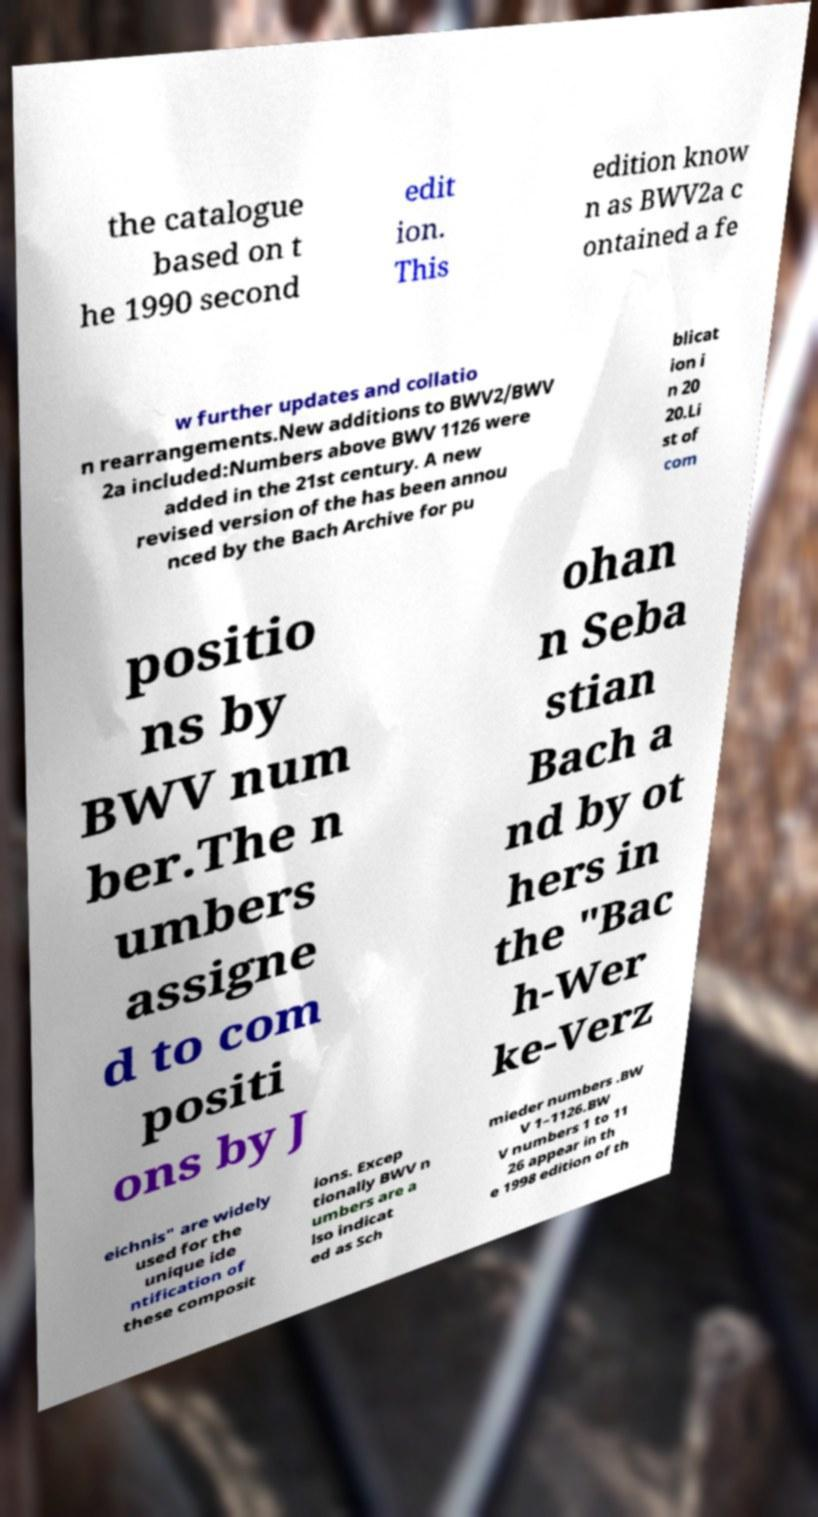For documentation purposes, I need the text within this image transcribed. Could you provide that? the catalogue based on t he 1990 second edit ion. This edition know n as BWV2a c ontained a fe w further updates and collatio n rearrangements.New additions to BWV2/BWV 2a included:Numbers above BWV 1126 were added in the 21st century. A new revised version of the has been annou nced by the Bach Archive for pu blicat ion i n 20 20.Li st of com positio ns by BWV num ber.The n umbers assigne d to com positi ons by J ohan n Seba stian Bach a nd by ot hers in the "Bac h-Wer ke-Verz eichnis" are widely used for the unique ide ntification of these composit ions. Excep tionally BWV n umbers are a lso indicat ed as Sch mieder numbers .BW V 1–1126.BW V numbers 1 to 11 26 appear in th e 1998 edition of th 